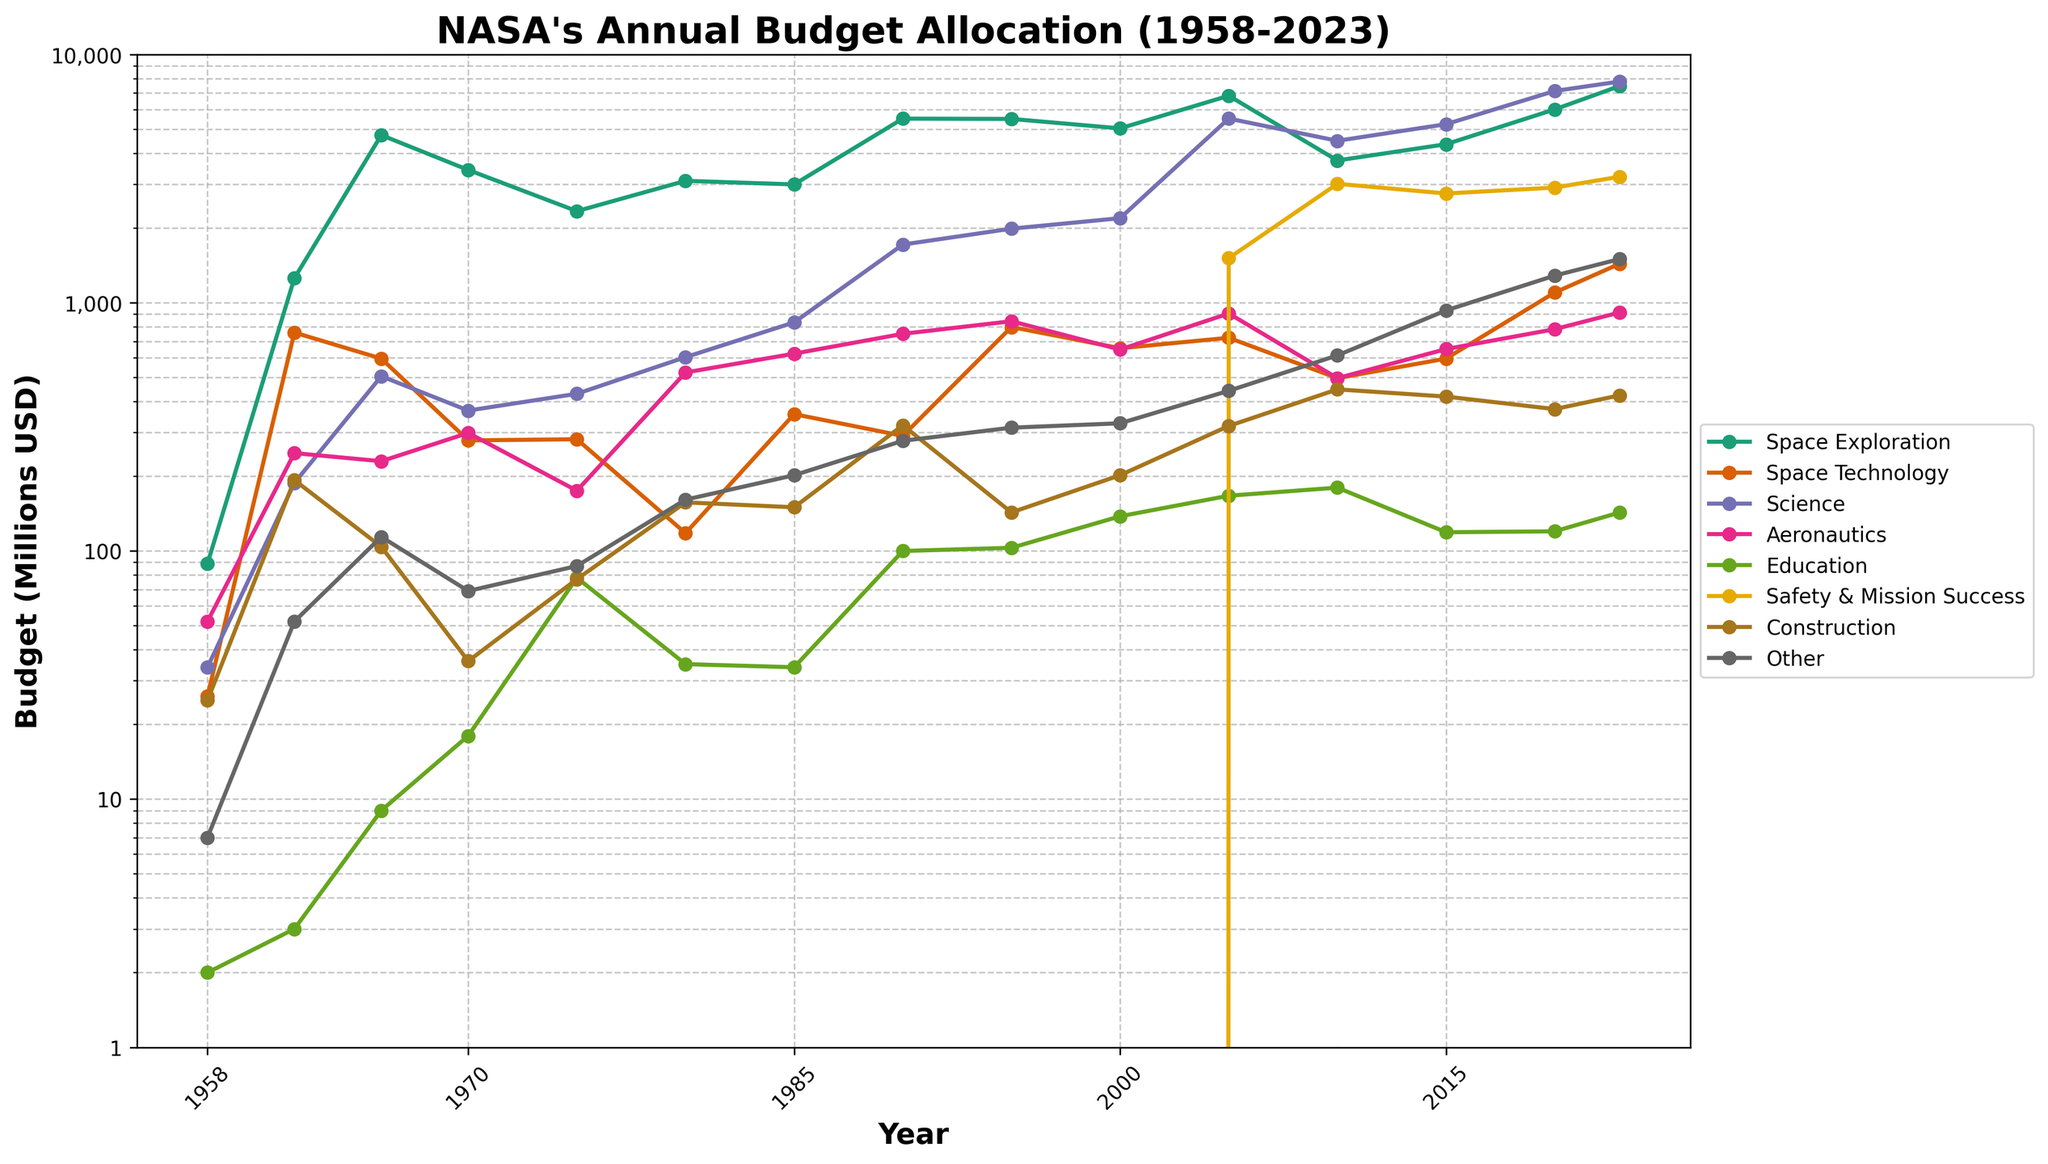What is the highest budget allocated to the Science program, and in which year did it occur? Firstly, locate the Science program line on the chart. Follow it to find the peak point, which appears to be the highest value. Check the corresponding year for this peak.
Answer: 7795 in 2023 Which program had the largest budget in 1966, and how much was it? Identify the budget values for each program in 1966. The tallest peak among these values corresponds to the largest budget. From the plot, it is the Space Exploration program.
Answer: Space Exploration, 4741 Between 1970 and 2023, how many times did the budget for Aeronautics surpass 700 million USD? Track the Aeronautics program line from 1970 to 2023. Count all instances where the budget crosses the 700 million USD mark.
Answer: Twice Compare the budget for Safety & Mission Success in 2010 and Education in 2023. Which one is higher and by how much? Identify the 2010 value for Safety & Mission Success and 2023 value for Education. Subtract the smaller budget from the larger to find the difference.
Answer: Safety & Mission Success is higher by 3080 million USD What was the total budget allocation for Space Technology and Aeronautics in 1995? Locate the budgets for Space Technology and Aeronautics in 1995. Sum these two values to get the total budget allocation.
Answer: 1642 (799 + 843) Which program saw the largest increase in budget allocation from 2005 to 2023? For each program, subtract the 2005 budget from the 2023 budget to find the increase. Identify the maximum value from these increases.
Answer: Science Identify the year when the Education budget first passed 100 million USD. Follow the Education program line until it first crosses the 100 million USD mark.
Answer: 1990 How does the budget for Construction in 2020 compare to that in 2015? Check the Construction budgets for both years. Subtract the 2015 value from the 2020 value to know the difference.
Answer: It is less by 46 million USD Provide the average budget for Space Exploration from 1985 to 2000. Sum the Space Exploration values from 1985, 1990, 1995, and 2000. Divide the total by the number of observations (4) to get the average.
Answer: 4770.5 Which program displayed a steady growth pattern with minimal budget fluctuations from 1958 to 2023? Visually inspect each program line in the plot for a relatively smooth and consistent upward trend without significant peaks or drops.
Answer: Space Technology 